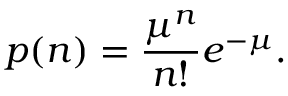<formula> <loc_0><loc_0><loc_500><loc_500>p ( n ) = \frac { \mu ^ { n } } { n ! } e ^ { - \mu } .</formula> 